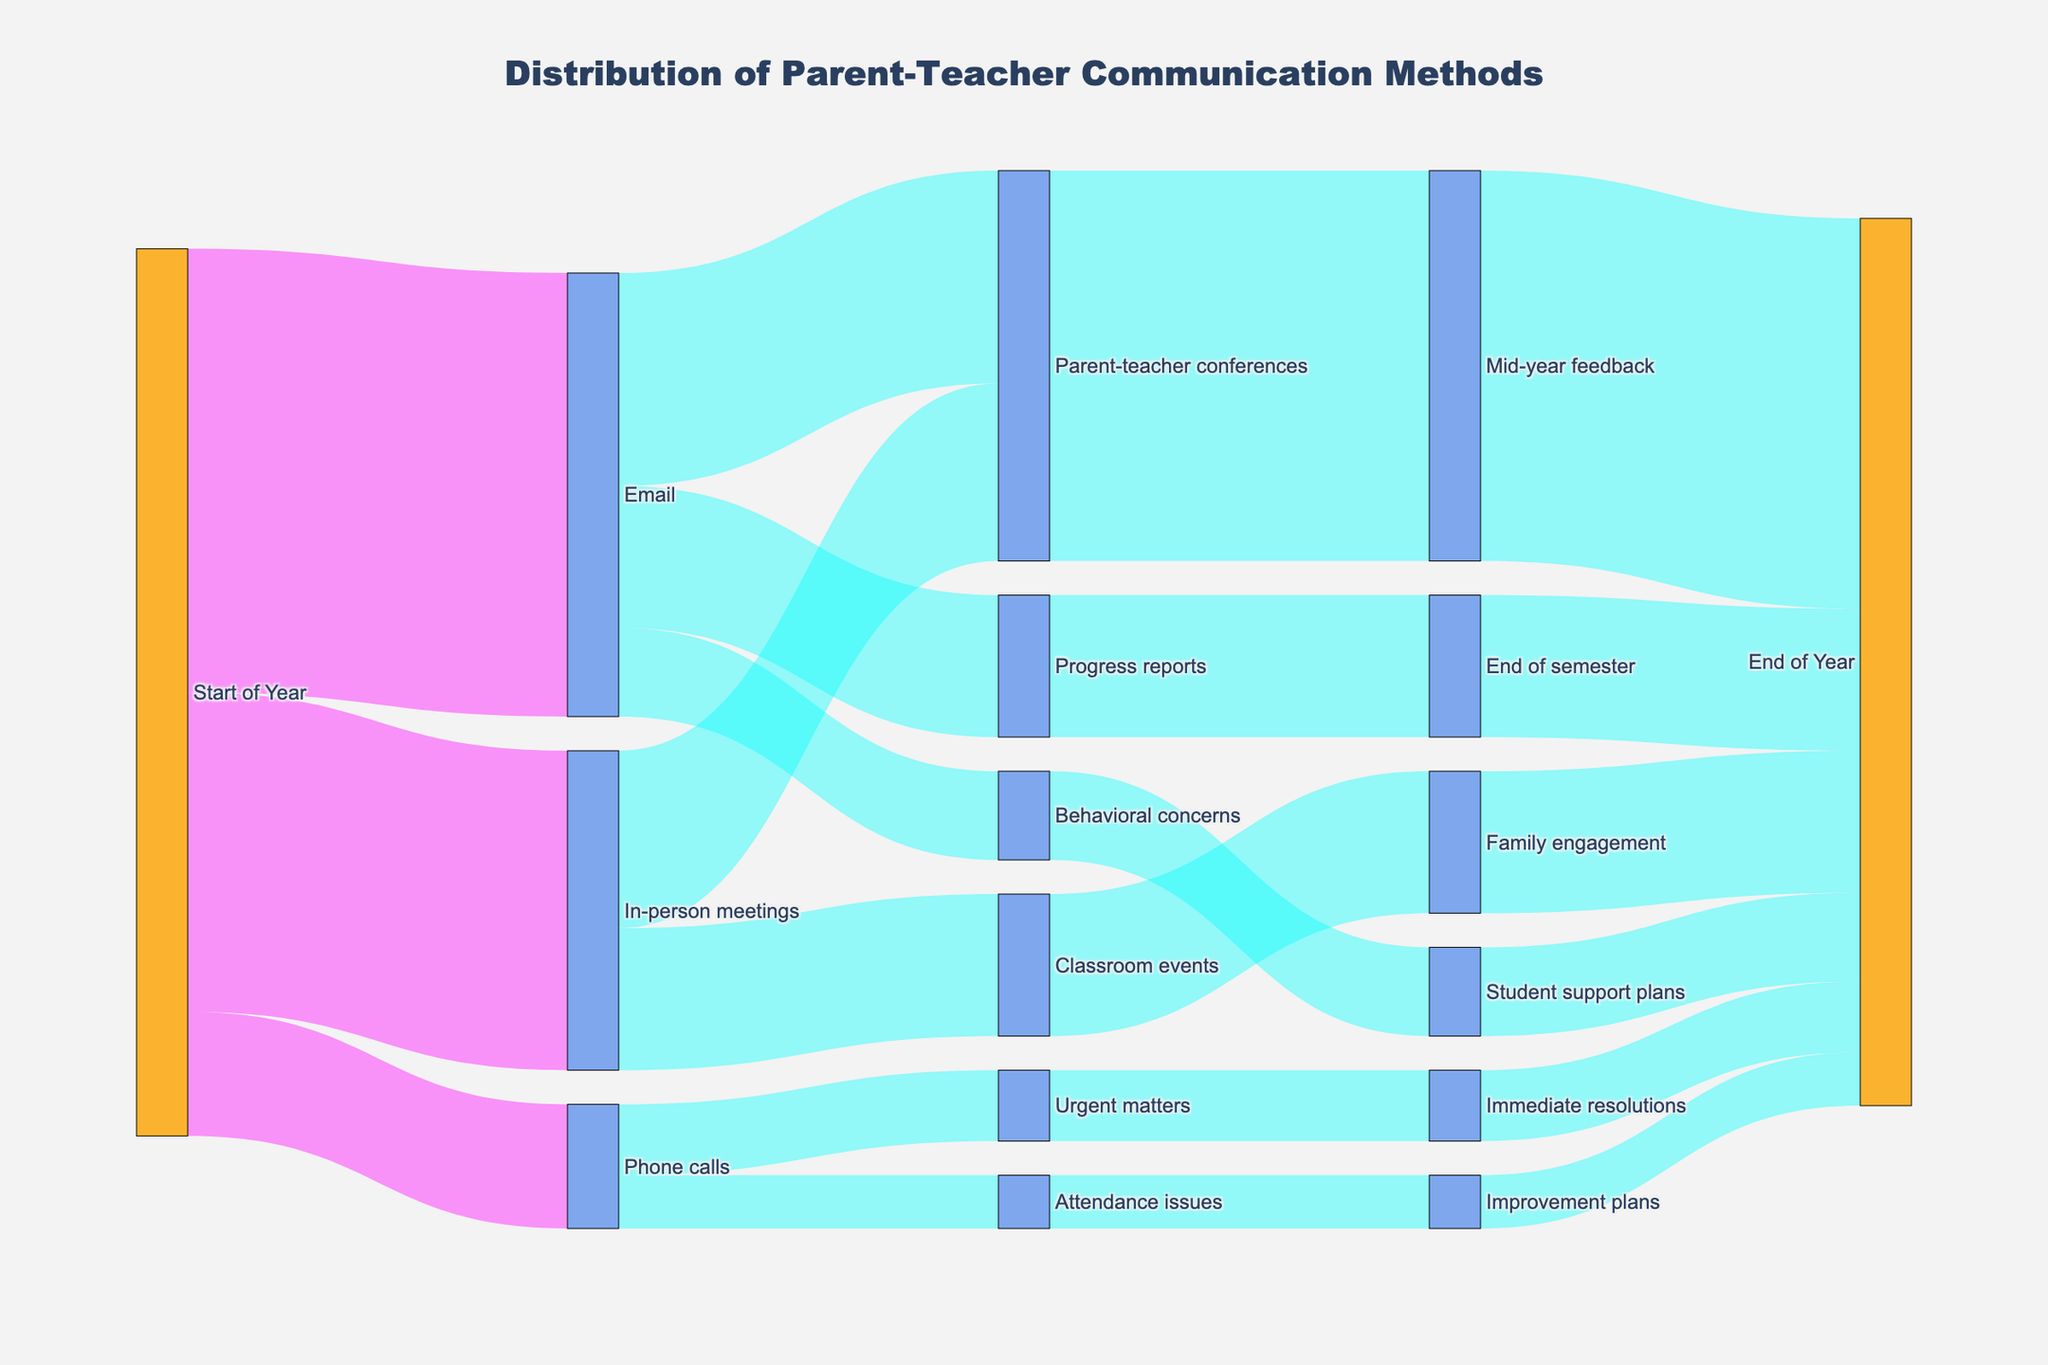What's the title of the diagram? The title is visualized at the top center of the diagram, it reads "Distribution of Parent-Teacher Communication Methods."
Answer: Distribution of Parent-Teacher Communication Methods How many parent-teacher communication methods are tracked at the start of the year? There are three methods visualized originating from the "Start of Year" node, they are "Email," "In-person meetings," and "Phone calls."
Answer: 3 What is the most common initial communication method used at the start of the year? The widths of the flows indicate the values; the flow from "Start of Year" to "Email" is the widest, which indicates the highest value, 250.
Answer: Email Which node has the highest outflow value? To find this, compare the total outflow values from each node. "Start of Year" has outflows of 250 (Email), 180 (In-person meetings), and 70 (Phone calls), totaling 500. None exceed this.
Answer: Start of Year (500) Which node is directly linked to "Student support plans"? The diagram shows an arrow pointing from "Behavioral concerns" to "Student support plans," suggesting a direct link.
Answer: Behavioral concerns How many communication methods lead to the "End of Year"? The diagram shows various connections culminating in the "End of Year" node. These include: "Mid-year feedback," "End of semester," "Student support plans," "Family engagement," "Immediate resolutions," and "Improvement plans," totaling 6.
Answer: 6 What is the total number of parents involved in "Parent-teacher conferences" across the year? Summing the values flowing into "Parent-teacher conferences": from "Email" (120) and "In-person meetings" (100), yields 120 + 100 = 220.
Answer: 220 Compare the values of "Phone calls" leading to "Urgent matters" and "Attendance issues." Which is higher? The diagram indicates "Phone calls" flows 40 to "Urgent matters" and 30 to "Attendance issues." The value of 40 is higher.
Answer: Urgent matters What is the cumulative value of parents using "In-person meetings" for "Classroom events"? From the diagram, the flow from "In-person meetings" to "Classroom events" has a value of 80.
Answer: 80 How many more parents receive "Progress reports" compared to those addressed for "Behavioral concerns"? This compares the values from "Email" flowing to "Progress reports" (80) against "Behavioral concerns" (50). The difference is 80 - 50 = 30.
Answer: 30 